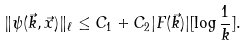Convert formula to latex. <formula><loc_0><loc_0><loc_500><loc_500>\| \psi ( \vec { k } , \vec { x } ) \| _ { \ell } \leq C _ { 1 } + C _ { 2 } | F ( \vec { k } ) | [ \log \frac { 1 } { k } ] .</formula> 